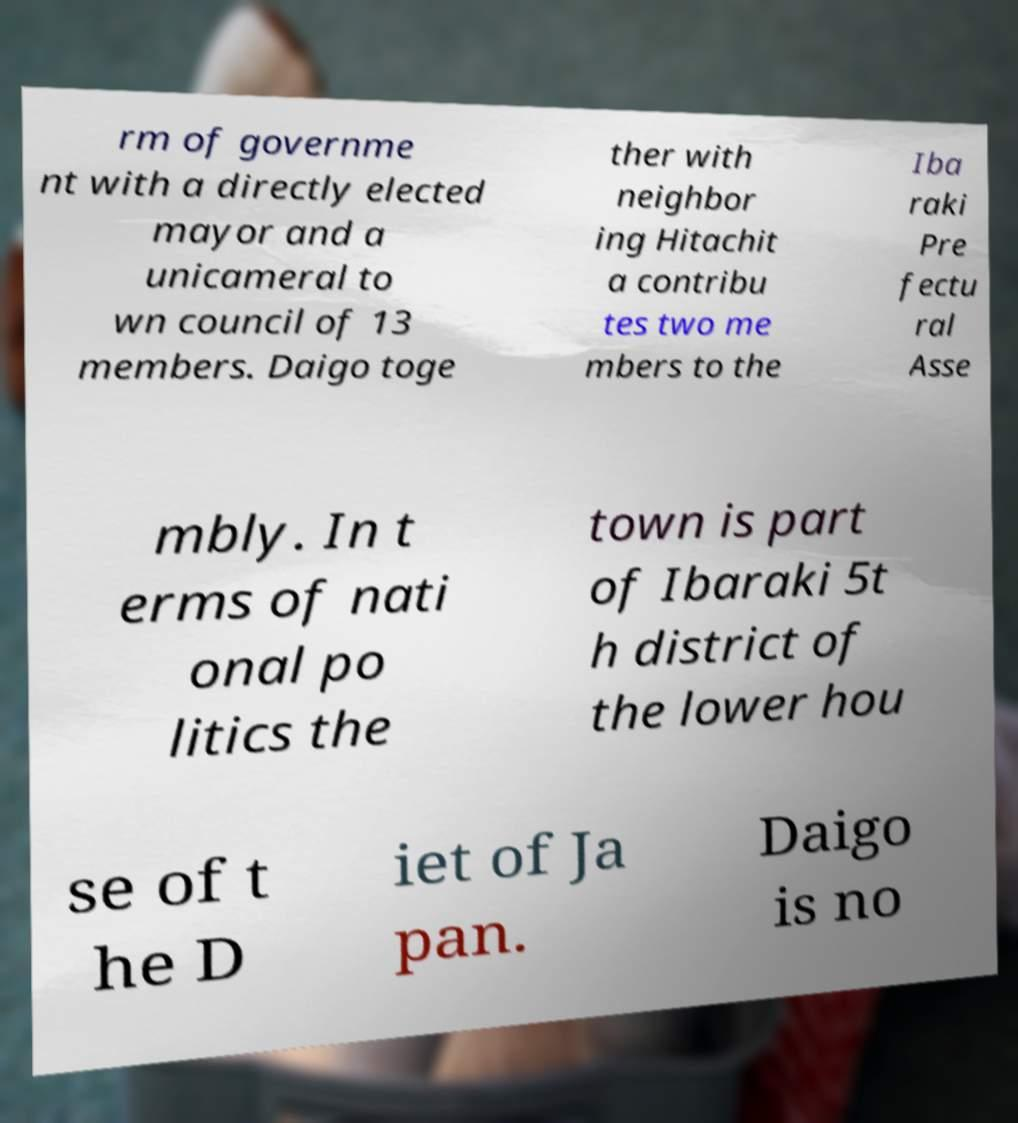Please identify and transcribe the text found in this image. rm of governme nt with a directly elected mayor and a unicameral to wn council of 13 members. Daigo toge ther with neighbor ing Hitachit a contribu tes two me mbers to the Iba raki Pre fectu ral Asse mbly. In t erms of nati onal po litics the town is part of Ibaraki 5t h district of the lower hou se of t he D iet of Ja pan. Daigo is no 